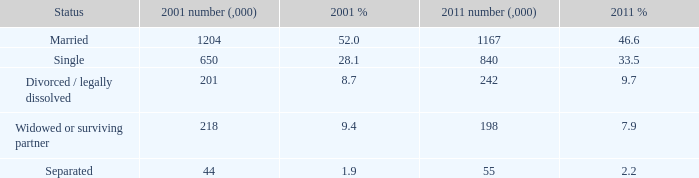How many 2011 % is 7.9? 1.0. 